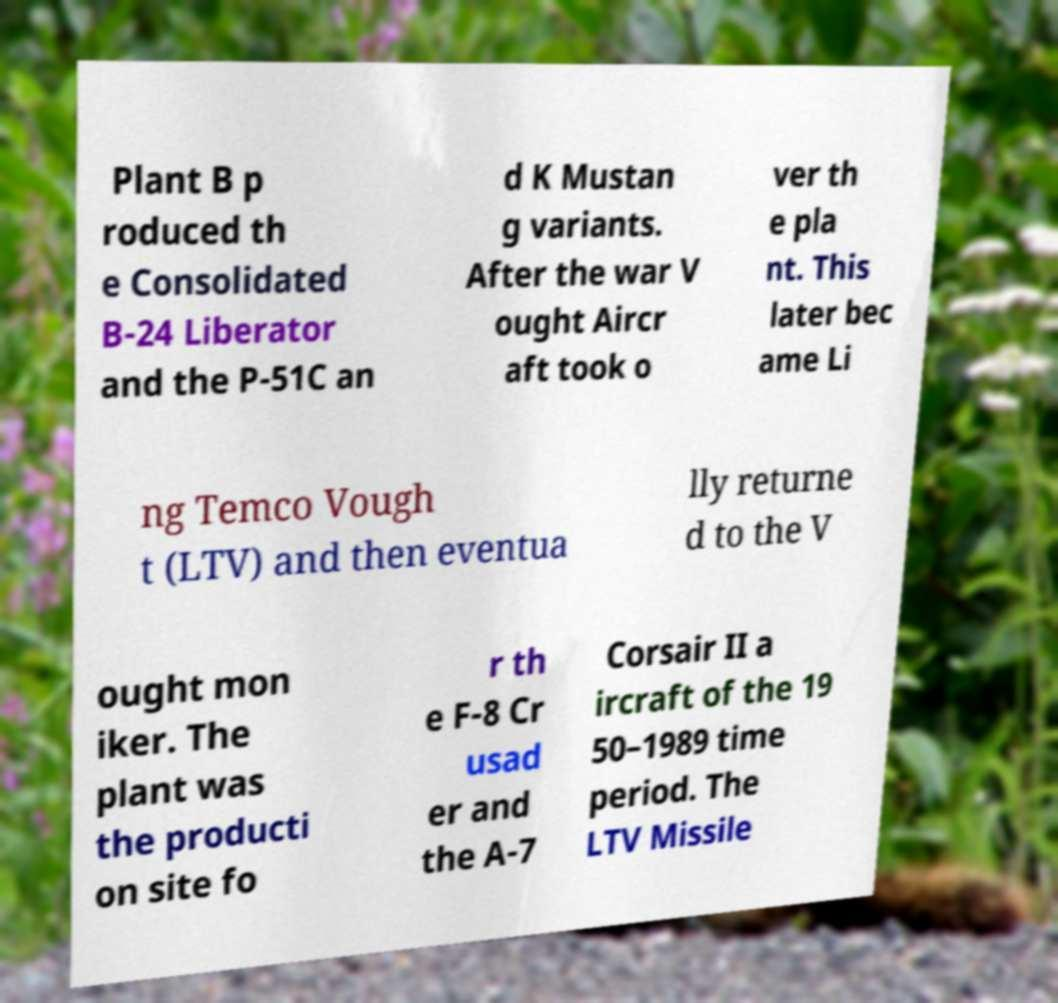Can you read and provide the text displayed in the image?This photo seems to have some interesting text. Can you extract and type it out for me? Plant B p roduced th e Consolidated B-24 Liberator and the P-51C an d K Mustan g variants. After the war V ought Aircr aft took o ver th e pla nt. This later bec ame Li ng Temco Vough t (LTV) and then eventua lly returne d to the V ought mon iker. The plant was the producti on site fo r th e F-8 Cr usad er and the A-7 Corsair II a ircraft of the 19 50–1989 time period. The LTV Missile 